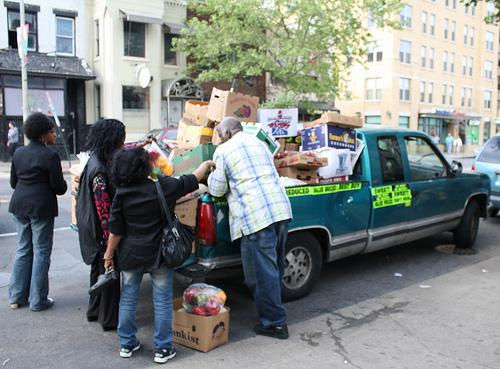Question: who is wearing the plaid shirt?
Choices:
A. The person on the left.
B. The adult.
C. The waiter.
D. The man.
Answer with the letter. Answer: D Question: where is the truck?
Choices:
A. On the road.
B. Parked on the street.
C. In the driveway.
D. By the sidewalk.
Answer with the letter. Answer: B Question: what is in the truck?
Choices:
A. Fruit.
B. Boxes of vegetables.
C. Bread.
D. Milk.
Answer with the letter. Answer: B Question: what time of day is it?
Choices:
A. Afternoon.
B. Daytime.
C. Late evening.
D. After lunch.
Answer with the letter. Answer: A 